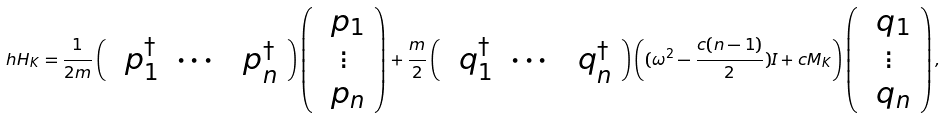<formula> <loc_0><loc_0><loc_500><loc_500>\ h H _ { K } = \frac { 1 } { 2 m } \left ( \begin{array} { c c c } \ p _ { 1 } ^ { \dagger } & \cdots & \ p _ { n } ^ { \dagger } \end{array} \right ) \left ( \begin{array} { c } \ p _ { 1 } \\ \vdots \\ \ p _ { n } \end{array} \right ) + \frac { m } { 2 } \left ( \begin{array} { c c c } \ q _ { 1 } ^ { \dagger } & \cdots & \ q _ { n } ^ { \dagger } \end{array} \right ) \left ( ( \omega ^ { 2 } - \frac { c ( n - 1 ) } { 2 } ) I + c M _ { K } \right ) \left ( \begin{array} { c } \ q _ { 1 } \\ \vdots \\ \ q _ { n } \end{array} \right ) ,</formula> 